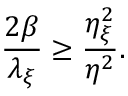Convert formula to latex. <formula><loc_0><loc_0><loc_500><loc_500>\frac { 2 \beta } { \lambda _ { \xi } } \geq \frac { \eta _ { \xi } ^ { 2 } } { \eta ^ { 2 } } .</formula> 